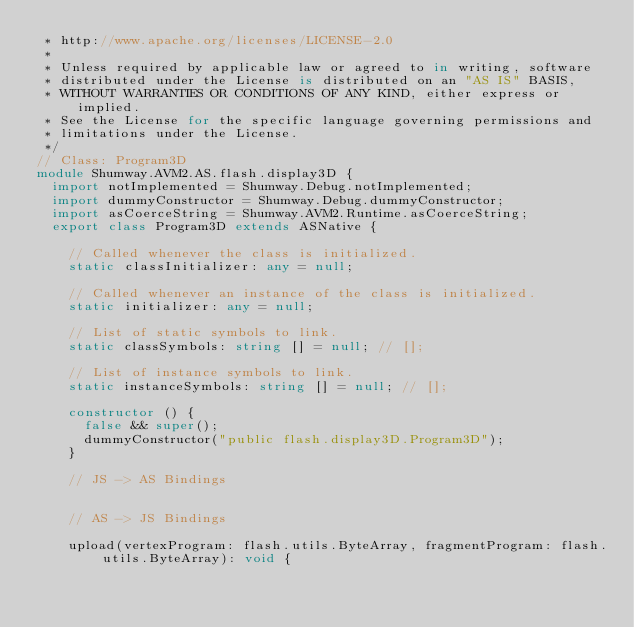Convert code to text. <code><loc_0><loc_0><loc_500><loc_500><_TypeScript_> * http://www.apache.org/licenses/LICENSE-2.0
 * 
 * Unless required by applicable law or agreed to in writing, software
 * distributed under the License is distributed on an "AS IS" BASIS,
 * WITHOUT WARRANTIES OR CONDITIONS OF ANY KIND, either express or implied.
 * See the License for the specific language governing permissions and
 * limitations under the License.
 */
// Class: Program3D
module Shumway.AVM2.AS.flash.display3D {
  import notImplemented = Shumway.Debug.notImplemented;
  import dummyConstructor = Shumway.Debug.dummyConstructor;
  import asCoerceString = Shumway.AVM2.Runtime.asCoerceString;
  export class Program3D extends ASNative {
    
    // Called whenever the class is initialized.
    static classInitializer: any = null;
    
    // Called whenever an instance of the class is initialized.
    static initializer: any = null;
    
    // List of static symbols to link.
    static classSymbols: string [] = null; // [];
    
    // List of instance symbols to link.
    static instanceSymbols: string [] = null; // [];
    
    constructor () {
      false && super();
      dummyConstructor("public flash.display3D.Program3D");
    }
    
    // JS -> AS Bindings
    
    
    // AS -> JS Bindings
    
    upload(vertexProgram: flash.utils.ByteArray, fragmentProgram: flash.utils.ByteArray): void {</code> 